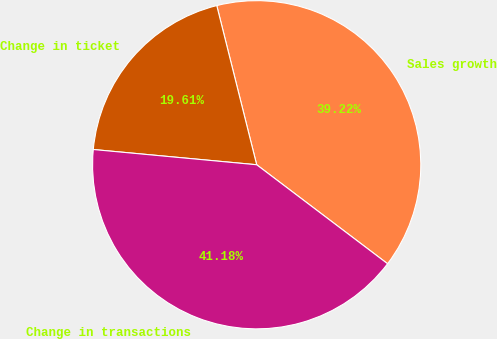Convert chart. <chart><loc_0><loc_0><loc_500><loc_500><pie_chart><fcel>Sales growth<fcel>Change in ticket<fcel>Change in transactions<nl><fcel>39.22%<fcel>19.61%<fcel>41.18%<nl></chart> 